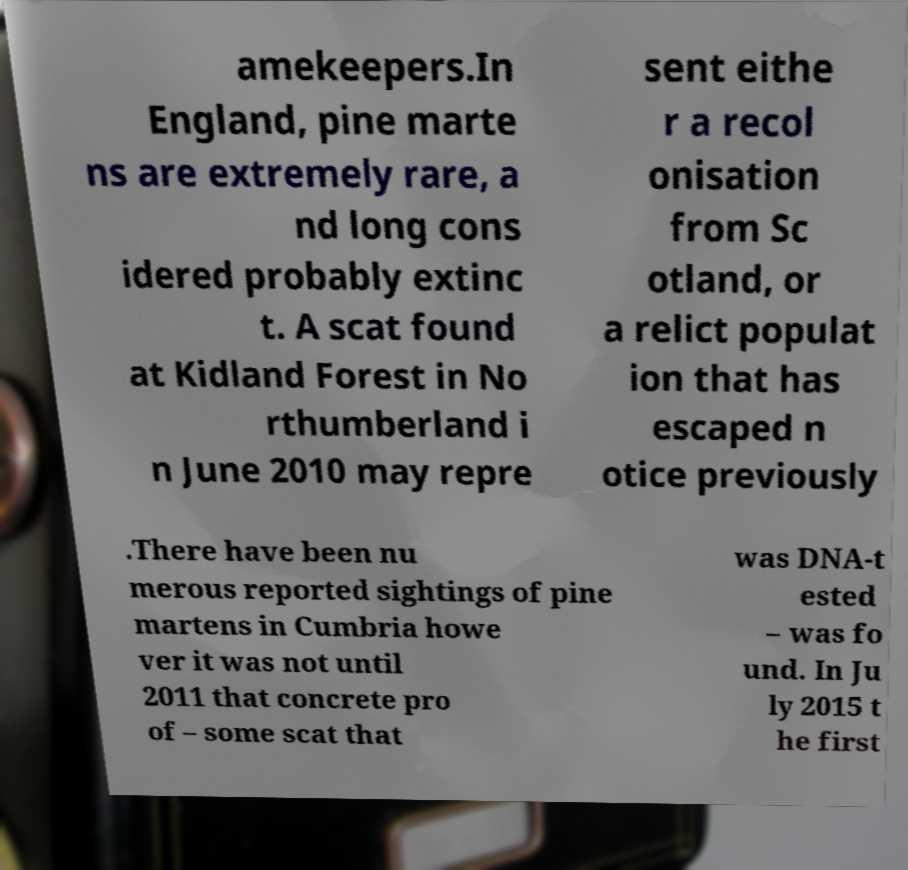What messages or text are displayed in this image? I need them in a readable, typed format. amekeepers.In England, pine marte ns are extremely rare, a nd long cons idered probably extinc t. A scat found at Kidland Forest in No rthumberland i n June 2010 may repre sent eithe r a recol onisation from Sc otland, or a relict populat ion that has escaped n otice previously .There have been nu merous reported sightings of pine martens in Cumbria howe ver it was not until 2011 that concrete pro of – some scat that was DNA-t ested – was fo und. In Ju ly 2015 t he first 